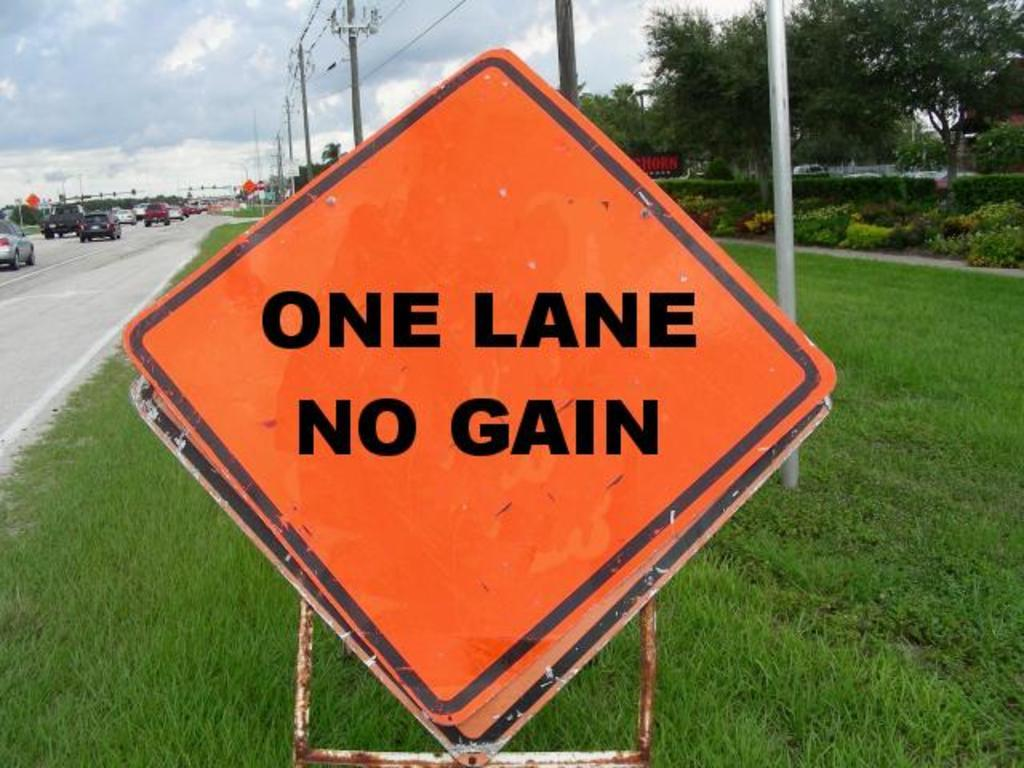Provide a one-sentence caption for the provided image. Sign on the side of a street saying One Lane No Gain. 